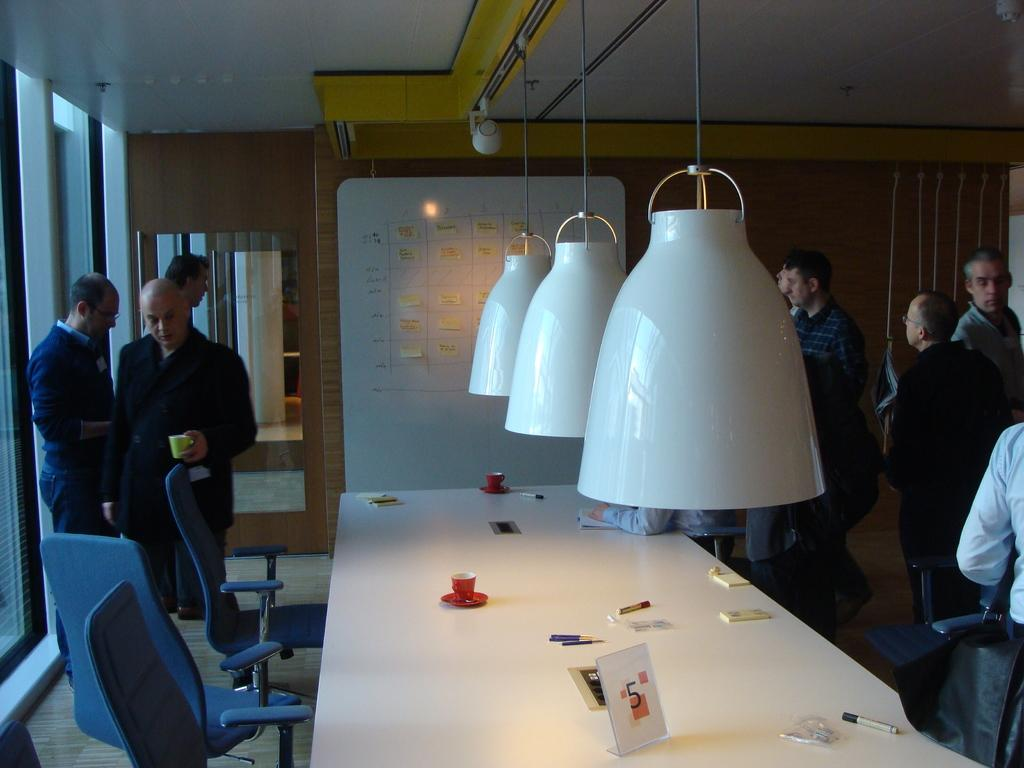How many people are in the image? There are people in the image, but the exact number is not specified. What are the people in the image doing? The people in the image are standing. What type of snakes can be seen slithering around the people in the image? There are no snakes present in the image; only people are mentioned. 